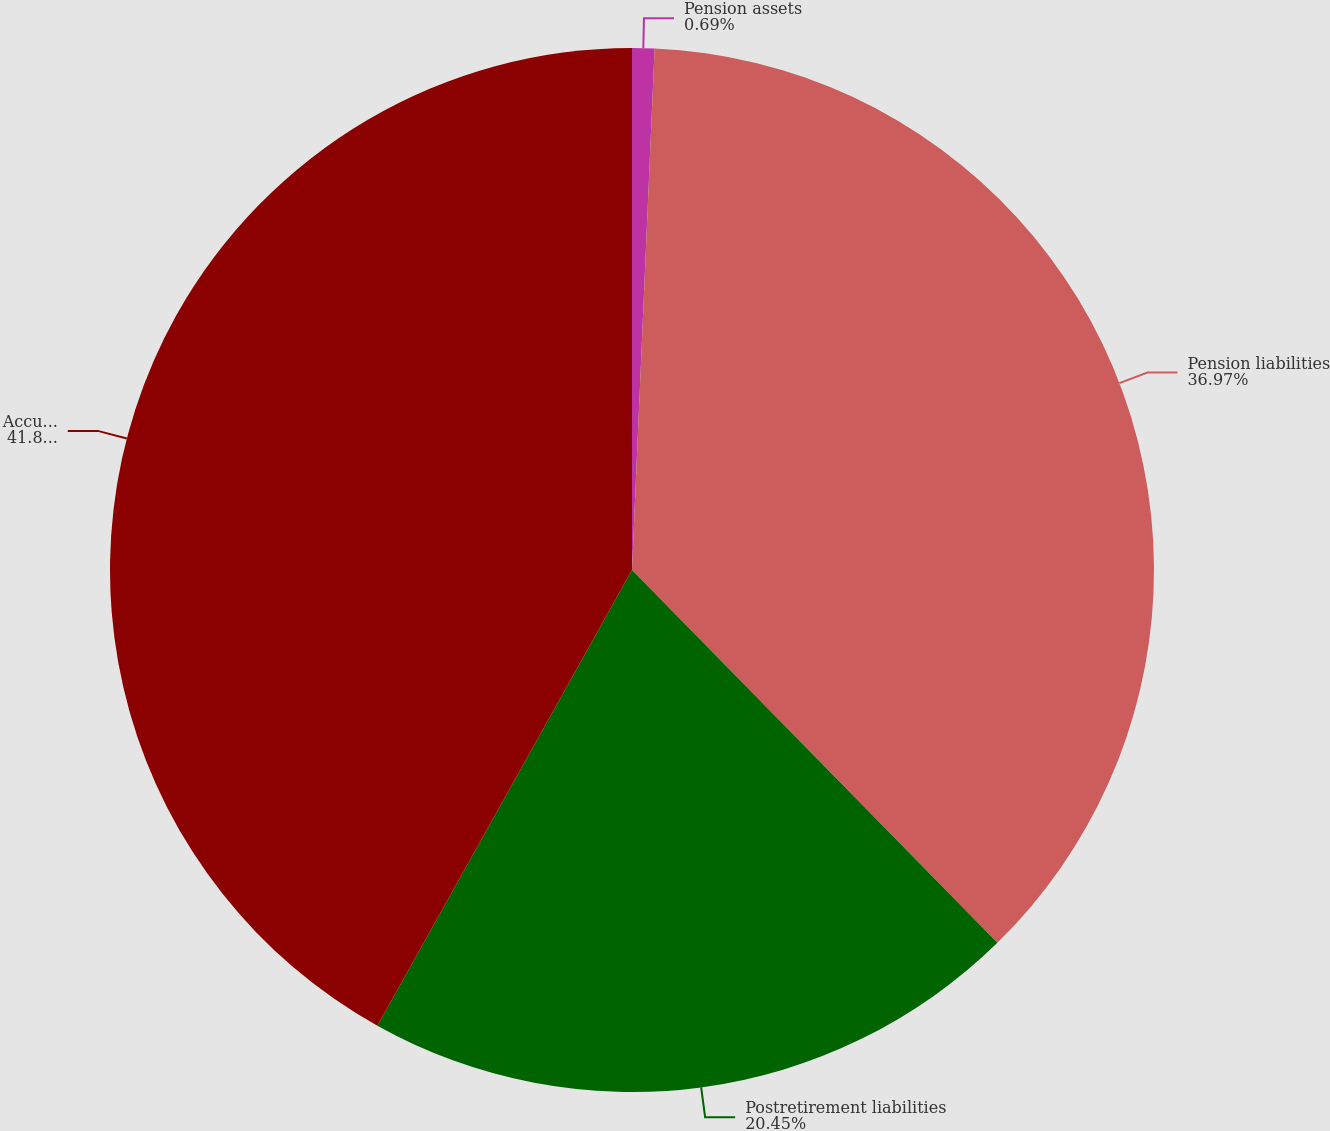<chart> <loc_0><loc_0><loc_500><loc_500><pie_chart><fcel>Pension assets<fcel>Pension liabilities<fcel>Postretirement liabilities<fcel>Accumulated other<nl><fcel>0.69%<fcel>36.97%<fcel>20.45%<fcel>41.89%<nl></chart> 